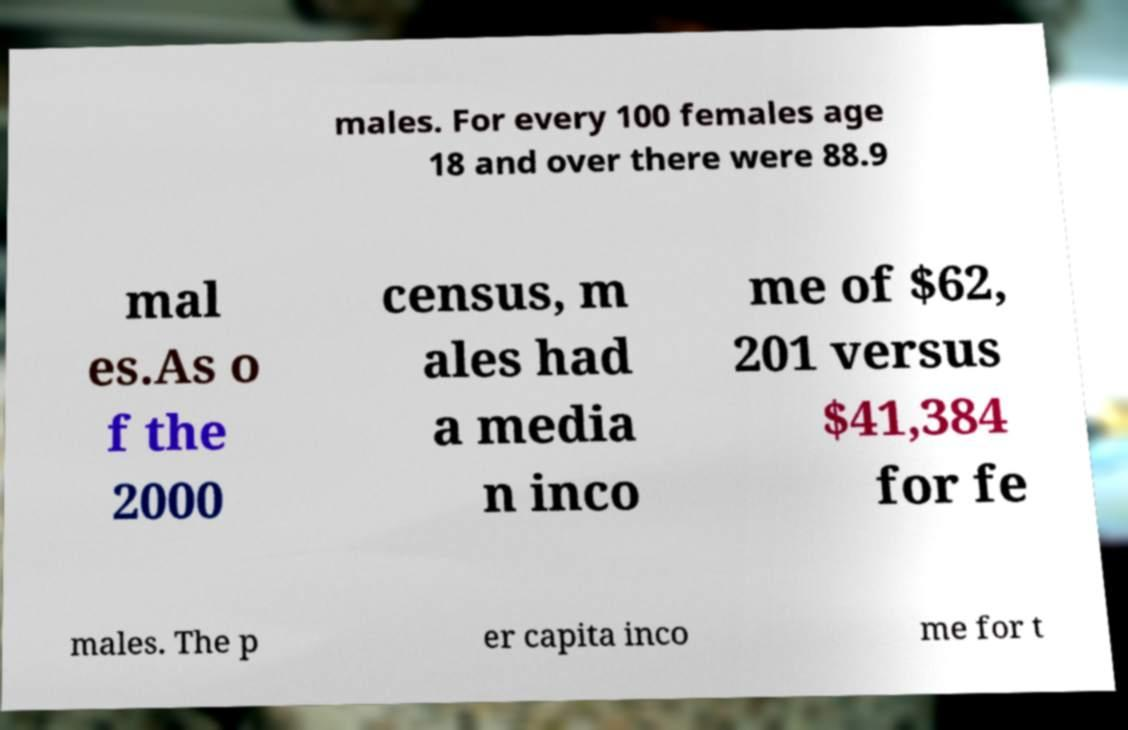I need the written content from this picture converted into text. Can you do that? males. For every 100 females age 18 and over there were 88.9 mal es.As o f the 2000 census, m ales had a media n inco me of $62, 201 versus $41,384 for fe males. The p er capita inco me for t 